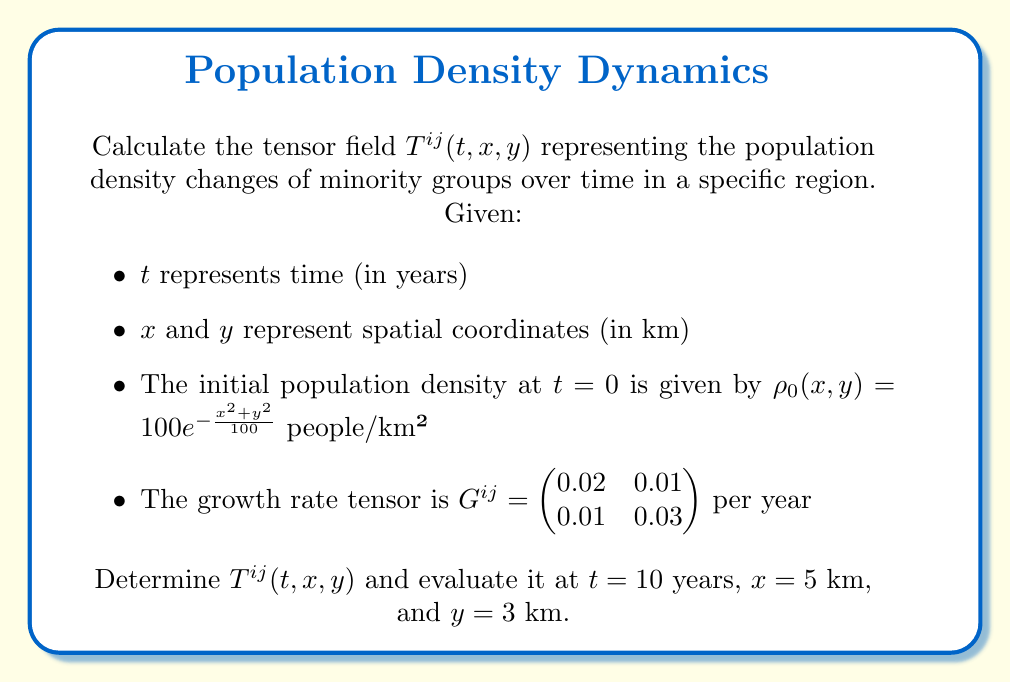Show me your answer to this math problem. To solve this problem, we'll follow these steps:

1) The tensor field $T^{ij}(t, x, y)$ represents the population density changes over time. It can be expressed as:

   $T^{ij}(t, x, y) = \rho_0(x,y) \cdot e^{G^{ij}t}$

2) We're given $\rho_0(x,y) = 100e^{-\frac{x^2+y^2}{100}}$ and $G^{ij} = \begin{pmatrix} 0.02 & 0.01 \\ 0.01 & 0.03 \end{pmatrix}$

3) To calculate $e^{G^{ij}t}$, we need to use the matrix exponential:

   $e^{G^{ij}t} = I + G^{ij}t + \frac{(G^{ij}t)^2}{2!} + \frac{(G^{ij}t)^3}{3!} + ...$

4) For $t=10$, we have:

   $e^{G^{ij}10} = I + 10G^{ij} + \frac{100(G^{ij})^2}{2} + \frac{1000(G^{ij})^3}{6} + ...$

5) Calculating the first few terms:

   $e^{G^{ij}10} \approx \begin{pmatrix} 1.2214 & 0.1107 \\ 0.1107 & 1.3499 \end{pmatrix}$

6) Now, we can write the full tensor field:

   $T^{ij}(t, x, y) = 100e^{-\frac{x^2+y^2}{100}} \cdot \begin{pmatrix} 1.2214e^{0.02t} & 0.1107e^{0.01t} \\ 0.1107e^{0.01t} & 1.3499e^{0.03t} \end{pmatrix}$

7) Evaluating at $t=10$, $x=5$, and $y=3$:

   $\rho_0(5,3) = 100e^{-\frac{5^2+3^2}{100}} \approx 78.4353$

   $T^{ij}(10, 5, 3) = 78.4353 \cdot \begin{pmatrix} 1.2214 & 0.1107 \\ 0.1107 & 1.3499 \end{pmatrix}$

8) Final result:

   $T^{ij}(10, 5, 3) \approx \begin{pmatrix} 95.8007 & 8.6828 \\ 8.6828 & 105.8816 \end{pmatrix}$ people/km²
Answer: $T^{ij}(10, 5, 3) \approx \begin{pmatrix} 95.8007 & 8.6828 \\ 8.6828 & 105.8816 \end{pmatrix}$ people/km² 